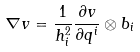<formula> <loc_0><loc_0><loc_500><loc_500>\nabla v = \frac { 1 } { h _ { i } ^ { 2 } } \frac { \partial v } { \partial q ^ { i } } \otimes b _ { i }</formula> 